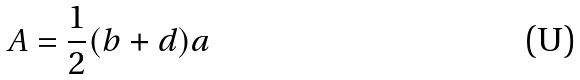<formula> <loc_0><loc_0><loc_500><loc_500>A = \frac { 1 } { 2 } ( b + d ) a</formula> 